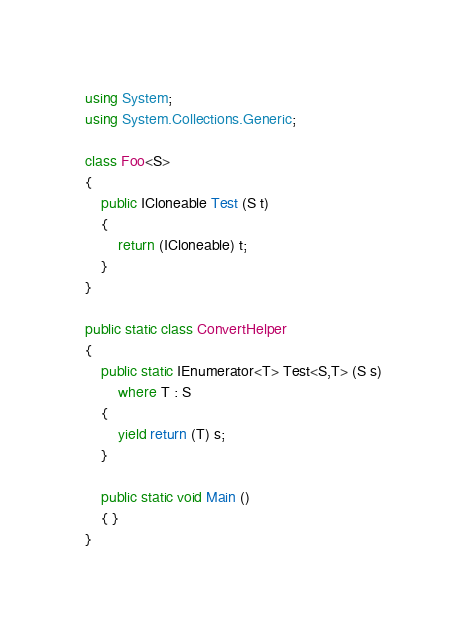Convert code to text. <code><loc_0><loc_0><loc_500><loc_500><_C#_>using System;
using System.Collections.Generic;

class Foo<S>
{
	public ICloneable Test (S t)
	{
		return (ICloneable) t;
	}
}

public static class ConvertHelper
{
	public static IEnumerator<T> Test<S,T> (S s)
		where T : S
	{
		yield return (T) s;
	}

	public static void Main ()
	{ }
}
</code> 